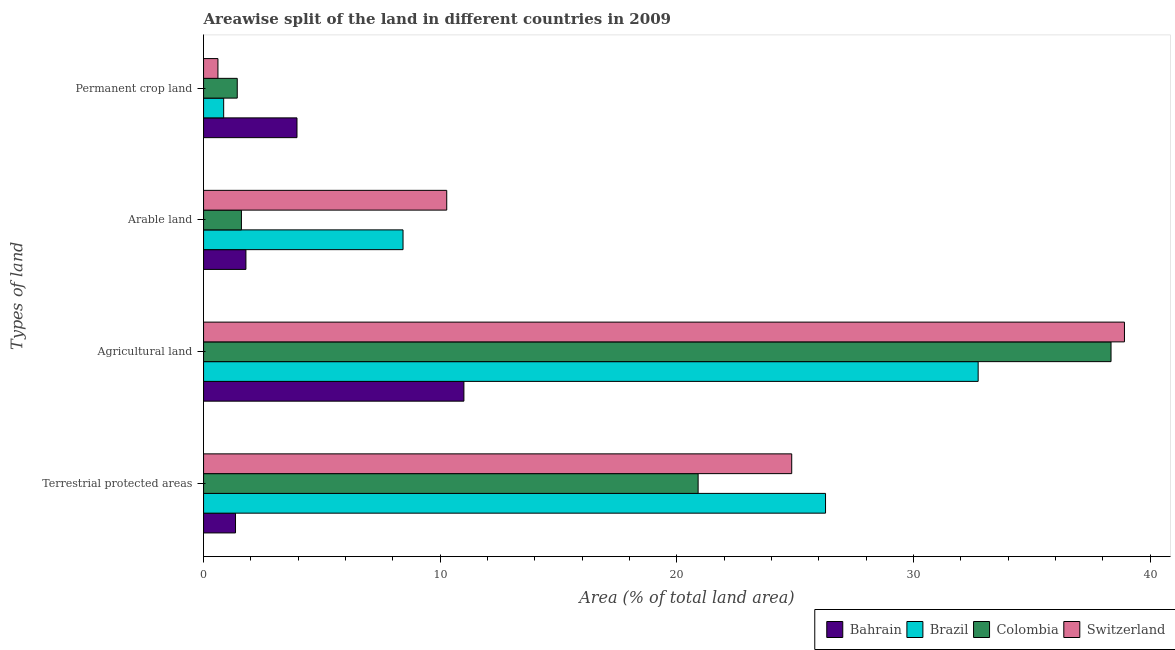How many groups of bars are there?
Provide a succinct answer. 4. How many bars are there on the 3rd tick from the bottom?
Offer a very short reply. 4. What is the label of the 1st group of bars from the top?
Provide a short and direct response. Permanent crop land. What is the percentage of land under terrestrial protection in Colombia?
Offer a very short reply. 20.9. Across all countries, what is the maximum percentage of area under arable land?
Keep it short and to the point. 10.27. Across all countries, what is the minimum percentage of area under permanent crop land?
Give a very brief answer. 0.61. In which country was the percentage of area under agricultural land maximum?
Your answer should be very brief. Switzerland. What is the total percentage of area under arable land in the graph?
Give a very brief answer. 22.09. What is the difference between the percentage of area under arable land in Bahrain and that in Brazil?
Your response must be concise. -6.64. What is the difference between the percentage of area under agricultural land in Switzerland and the percentage of area under arable land in Bahrain?
Your response must be concise. 37.12. What is the average percentage of area under arable land per country?
Keep it short and to the point. 5.52. What is the difference between the percentage of area under arable land and percentage of land under terrestrial protection in Switzerland?
Keep it short and to the point. -14.58. What is the ratio of the percentage of area under agricultural land in Brazil to that in Colombia?
Your answer should be compact. 0.85. What is the difference between the highest and the second highest percentage of area under permanent crop land?
Provide a succinct answer. 2.52. What is the difference between the highest and the lowest percentage of land under terrestrial protection?
Your answer should be compact. 24.93. Is it the case that in every country, the sum of the percentage of area under permanent crop land and percentage of area under agricultural land is greater than the sum of percentage of area under arable land and percentage of land under terrestrial protection?
Make the answer very short. Yes. What does the 3rd bar from the top in Arable land represents?
Offer a very short reply. Brazil. What does the 4th bar from the bottom in Terrestrial protected areas represents?
Your answer should be compact. Switzerland. Is it the case that in every country, the sum of the percentage of land under terrestrial protection and percentage of area under agricultural land is greater than the percentage of area under arable land?
Give a very brief answer. Yes. Are the values on the major ticks of X-axis written in scientific E-notation?
Offer a very short reply. No. Does the graph contain any zero values?
Ensure brevity in your answer.  No. Does the graph contain grids?
Give a very brief answer. No. Where does the legend appear in the graph?
Your answer should be compact. Bottom right. How are the legend labels stacked?
Your answer should be very brief. Horizontal. What is the title of the graph?
Keep it short and to the point. Areawise split of the land in different countries in 2009. Does "Somalia" appear as one of the legend labels in the graph?
Your answer should be compact. No. What is the label or title of the X-axis?
Offer a terse response. Area (% of total land area). What is the label or title of the Y-axis?
Offer a terse response. Types of land. What is the Area (% of total land area) of Bahrain in Terrestrial protected areas?
Your response must be concise. 1.35. What is the Area (% of total land area) of Brazil in Terrestrial protected areas?
Keep it short and to the point. 26.28. What is the Area (% of total land area) of Colombia in Terrestrial protected areas?
Ensure brevity in your answer.  20.9. What is the Area (% of total land area) of Switzerland in Terrestrial protected areas?
Offer a terse response. 24.85. What is the Area (% of total land area) of Bahrain in Agricultural land?
Offer a terse response. 11. What is the Area (% of total land area) of Brazil in Agricultural land?
Your response must be concise. 32.73. What is the Area (% of total land area) in Colombia in Agricultural land?
Keep it short and to the point. 38.34. What is the Area (% of total land area) of Switzerland in Agricultural land?
Keep it short and to the point. 38.91. What is the Area (% of total land area) in Bahrain in Arable land?
Ensure brevity in your answer.  1.79. What is the Area (% of total land area) of Brazil in Arable land?
Provide a succinct answer. 8.43. What is the Area (% of total land area) in Colombia in Arable land?
Ensure brevity in your answer.  1.6. What is the Area (% of total land area) of Switzerland in Arable land?
Offer a terse response. 10.27. What is the Area (% of total land area) of Bahrain in Permanent crop land?
Provide a succinct answer. 3.95. What is the Area (% of total land area) in Brazil in Permanent crop land?
Give a very brief answer. 0.85. What is the Area (% of total land area) of Colombia in Permanent crop land?
Give a very brief answer. 1.42. What is the Area (% of total land area) of Switzerland in Permanent crop land?
Keep it short and to the point. 0.61. Across all Types of land, what is the maximum Area (% of total land area) in Bahrain?
Provide a short and direct response. 11. Across all Types of land, what is the maximum Area (% of total land area) of Brazil?
Your answer should be very brief. 32.73. Across all Types of land, what is the maximum Area (% of total land area) in Colombia?
Provide a short and direct response. 38.34. Across all Types of land, what is the maximum Area (% of total land area) of Switzerland?
Your response must be concise. 38.91. Across all Types of land, what is the minimum Area (% of total land area) of Bahrain?
Your response must be concise. 1.35. Across all Types of land, what is the minimum Area (% of total land area) in Brazil?
Offer a very short reply. 0.85. Across all Types of land, what is the minimum Area (% of total land area) in Colombia?
Offer a terse response. 1.42. Across all Types of land, what is the minimum Area (% of total land area) in Switzerland?
Make the answer very short. 0.61. What is the total Area (% of total land area) of Bahrain in the graph?
Keep it short and to the point. 18.09. What is the total Area (% of total land area) in Brazil in the graph?
Give a very brief answer. 68.28. What is the total Area (% of total land area) of Colombia in the graph?
Keep it short and to the point. 62.26. What is the total Area (% of total land area) in Switzerland in the graph?
Give a very brief answer. 74.64. What is the difference between the Area (% of total land area) in Bahrain in Terrestrial protected areas and that in Agricultural land?
Make the answer very short. -9.65. What is the difference between the Area (% of total land area) in Brazil in Terrestrial protected areas and that in Agricultural land?
Your answer should be very brief. -6.45. What is the difference between the Area (% of total land area) in Colombia in Terrestrial protected areas and that in Agricultural land?
Offer a terse response. -17.45. What is the difference between the Area (% of total land area) in Switzerland in Terrestrial protected areas and that in Agricultural land?
Offer a terse response. -14.06. What is the difference between the Area (% of total land area) in Bahrain in Terrestrial protected areas and that in Arable land?
Ensure brevity in your answer.  -0.44. What is the difference between the Area (% of total land area) in Brazil in Terrestrial protected areas and that in Arable land?
Your answer should be compact. 17.85. What is the difference between the Area (% of total land area) of Colombia in Terrestrial protected areas and that in Arable land?
Your answer should be very brief. 19.3. What is the difference between the Area (% of total land area) in Switzerland in Terrestrial protected areas and that in Arable land?
Keep it short and to the point. 14.58. What is the difference between the Area (% of total land area) in Bahrain in Terrestrial protected areas and that in Permanent crop land?
Provide a short and direct response. -2.6. What is the difference between the Area (% of total land area) of Brazil in Terrestrial protected areas and that in Permanent crop land?
Provide a short and direct response. 25.43. What is the difference between the Area (% of total land area) in Colombia in Terrestrial protected areas and that in Permanent crop land?
Make the answer very short. 19.47. What is the difference between the Area (% of total land area) in Switzerland in Terrestrial protected areas and that in Permanent crop land?
Offer a very short reply. 24.24. What is the difference between the Area (% of total land area) of Bahrain in Agricultural land and that in Arable land?
Offer a terse response. 9.21. What is the difference between the Area (% of total land area) of Brazil in Agricultural land and that in Arable land?
Provide a succinct answer. 24.3. What is the difference between the Area (% of total land area) in Colombia in Agricultural land and that in Arable land?
Your response must be concise. 36.74. What is the difference between the Area (% of total land area) in Switzerland in Agricultural land and that in Arable land?
Ensure brevity in your answer.  28.63. What is the difference between the Area (% of total land area) of Bahrain in Agricultural land and that in Permanent crop land?
Offer a terse response. 7.05. What is the difference between the Area (% of total land area) of Brazil in Agricultural land and that in Permanent crop land?
Provide a succinct answer. 31.88. What is the difference between the Area (% of total land area) in Colombia in Agricultural land and that in Permanent crop land?
Keep it short and to the point. 36.92. What is the difference between the Area (% of total land area) of Switzerland in Agricultural land and that in Permanent crop land?
Provide a succinct answer. 38.3. What is the difference between the Area (% of total land area) in Bahrain in Arable land and that in Permanent crop land?
Ensure brevity in your answer.  -2.16. What is the difference between the Area (% of total land area) of Brazil in Arable land and that in Permanent crop land?
Give a very brief answer. 7.58. What is the difference between the Area (% of total land area) of Colombia in Arable land and that in Permanent crop land?
Provide a short and direct response. 0.18. What is the difference between the Area (% of total land area) of Switzerland in Arable land and that in Permanent crop land?
Your answer should be compact. 9.67. What is the difference between the Area (% of total land area) of Bahrain in Terrestrial protected areas and the Area (% of total land area) of Brazil in Agricultural land?
Provide a succinct answer. -31.38. What is the difference between the Area (% of total land area) of Bahrain in Terrestrial protected areas and the Area (% of total land area) of Colombia in Agricultural land?
Give a very brief answer. -36.99. What is the difference between the Area (% of total land area) in Bahrain in Terrestrial protected areas and the Area (% of total land area) in Switzerland in Agricultural land?
Ensure brevity in your answer.  -37.56. What is the difference between the Area (% of total land area) of Brazil in Terrestrial protected areas and the Area (% of total land area) of Colombia in Agricultural land?
Offer a very short reply. -12.06. What is the difference between the Area (% of total land area) of Brazil in Terrestrial protected areas and the Area (% of total land area) of Switzerland in Agricultural land?
Your answer should be compact. -12.63. What is the difference between the Area (% of total land area) in Colombia in Terrestrial protected areas and the Area (% of total land area) in Switzerland in Agricultural land?
Your answer should be compact. -18.01. What is the difference between the Area (% of total land area) in Bahrain in Terrestrial protected areas and the Area (% of total land area) in Brazil in Arable land?
Offer a very short reply. -7.08. What is the difference between the Area (% of total land area) of Bahrain in Terrestrial protected areas and the Area (% of total land area) of Switzerland in Arable land?
Give a very brief answer. -8.92. What is the difference between the Area (% of total land area) of Brazil in Terrestrial protected areas and the Area (% of total land area) of Colombia in Arable land?
Ensure brevity in your answer.  24.68. What is the difference between the Area (% of total land area) in Brazil in Terrestrial protected areas and the Area (% of total land area) in Switzerland in Arable land?
Provide a succinct answer. 16. What is the difference between the Area (% of total land area) of Colombia in Terrestrial protected areas and the Area (% of total land area) of Switzerland in Arable land?
Offer a terse response. 10.62. What is the difference between the Area (% of total land area) in Bahrain in Terrestrial protected areas and the Area (% of total land area) in Brazil in Permanent crop land?
Give a very brief answer. 0.5. What is the difference between the Area (% of total land area) in Bahrain in Terrestrial protected areas and the Area (% of total land area) in Colombia in Permanent crop land?
Make the answer very short. -0.07. What is the difference between the Area (% of total land area) in Bahrain in Terrestrial protected areas and the Area (% of total land area) in Switzerland in Permanent crop land?
Provide a succinct answer. 0.74. What is the difference between the Area (% of total land area) of Brazil in Terrestrial protected areas and the Area (% of total land area) of Colombia in Permanent crop land?
Your answer should be very brief. 24.86. What is the difference between the Area (% of total land area) of Brazil in Terrestrial protected areas and the Area (% of total land area) of Switzerland in Permanent crop land?
Your answer should be very brief. 25.67. What is the difference between the Area (% of total land area) of Colombia in Terrestrial protected areas and the Area (% of total land area) of Switzerland in Permanent crop land?
Your answer should be compact. 20.29. What is the difference between the Area (% of total land area) in Bahrain in Agricultural land and the Area (% of total land area) in Brazil in Arable land?
Your answer should be very brief. 2.57. What is the difference between the Area (% of total land area) in Bahrain in Agricultural land and the Area (% of total land area) in Colombia in Arable land?
Make the answer very short. 9.4. What is the difference between the Area (% of total land area) of Bahrain in Agricultural land and the Area (% of total land area) of Switzerland in Arable land?
Provide a short and direct response. 0.73. What is the difference between the Area (% of total land area) in Brazil in Agricultural land and the Area (% of total land area) in Colombia in Arable land?
Your answer should be compact. 31.13. What is the difference between the Area (% of total land area) of Brazil in Agricultural land and the Area (% of total land area) of Switzerland in Arable land?
Your answer should be compact. 22.45. What is the difference between the Area (% of total land area) of Colombia in Agricultural land and the Area (% of total land area) of Switzerland in Arable land?
Provide a succinct answer. 28.07. What is the difference between the Area (% of total land area) in Bahrain in Agricultural land and the Area (% of total land area) in Brazil in Permanent crop land?
Make the answer very short. 10.15. What is the difference between the Area (% of total land area) in Bahrain in Agricultural land and the Area (% of total land area) in Colombia in Permanent crop land?
Offer a terse response. 9.58. What is the difference between the Area (% of total land area) of Bahrain in Agricultural land and the Area (% of total land area) of Switzerland in Permanent crop land?
Give a very brief answer. 10.39. What is the difference between the Area (% of total land area) in Brazil in Agricultural land and the Area (% of total land area) in Colombia in Permanent crop land?
Your response must be concise. 31.3. What is the difference between the Area (% of total land area) in Brazil in Agricultural land and the Area (% of total land area) in Switzerland in Permanent crop land?
Offer a terse response. 32.12. What is the difference between the Area (% of total land area) of Colombia in Agricultural land and the Area (% of total land area) of Switzerland in Permanent crop land?
Your answer should be very brief. 37.73. What is the difference between the Area (% of total land area) of Bahrain in Arable land and the Area (% of total land area) of Colombia in Permanent crop land?
Provide a short and direct response. 0.37. What is the difference between the Area (% of total land area) of Bahrain in Arable land and the Area (% of total land area) of Switzerland in Permanent crop land?
Offer a very short reply. 1.18. What is the difference between the Area (% of total land area) of Brazil in Arable land and the Area (% of total land area) of Colombia in Permanent crop land?
Your answer should be compact. 7. What is the difference between the Area (% of total land area) of Brazil in Arable land and the Area (% of total land area) of Switzerland in Permanent crop land?
Provide a succinct answer. 7.82. What is the average Area (% of total land area) in Bahrain per Types of land?
Ensure brevity in your answer.  4.52. What is the average Area (% of total land area) in Brazil per Types of land?
Offer a terse response. 17.07. What is the average Area (% of total land area) in Colombia per Types of land?
Your answer should be very brief. 15.57. What is the average Area (% of total land area) in Switzerland per Types of land?
Make the answer very short. 18.66. What is the difference between the Area (% of total land area) in Bahrain and Area (% of total land area) in Brazil in Terrestrial protected areas?
Provide a succinct answer. -24.93. What is the difference between the Area (% of total land area) of Bahrain and Area (% of total land area) of Colombia in Terrestrial protected areas?
Give a very brief answer. -19.55. What is the difference between the Area (% of total land area) in Bahrain and Area (% of total land area) in Switzerland in Terrestrial protected areas?
Give a very brief answer. -23.5. What is the difference between the Area (% of total land area) in Brazil and Area (% of total land area) in Colombia in Terrestrial protected areas?
Ensure brevity in your answer.  5.38. What is the difference between the Area (% of total land area) of Brazil and Area (% of total land area) of Switzerland in Terrestrial protected areas?
Provide a short and direct response. 1.43. What is the difference between the Area (% of total land area) in Colombia and Area (% of total land area) in Switzerland in Terrestrial protected areas?
Your answer should be compact. -3.95. What is the difference between the Area (% of total land area) of Bahrain and Area (% of total land area) of Brazil in Agricultural land?
Provide a short and direct response. -21.73. What is the difference between the Area (% of total land area) in Bahrain and Area (% of total land area) in Colombia in Agricultural land?
Make the answer very short. -27.34. What is the difference between the Area (% of total land area) in Bahrain and Area (% of total land area) in Switzerland in Agricultural land?
Keep it short and to the point. -27.91. What is the difference between the Area (% of total land area) in Brazil and Area (% of total land area) in Colombia in Agricultural land?
Provide a succinct answer. -5.61. What is the difference between the Area (% of total land area) of Brazil and Area (% of total land area) of Switzerland in Agricultural land?
Make the answer very short. -6.18. What is the difference between the Area (% of total land area) of Colombia and Area (% of total land area) of Switzerland in Agricultural land?
Provide a succinct answer. -0.57. What is the difference between the Area (% of total land area) in Bahrain and Area (% of total land area) in Brazil in Arable land?
Offer a terse response. -6.64. What is the difference between the Area (% of total land area) of Bahrain and Area (% of total land area) of Colombia in Arable land?
Ensure brevity in your answer.  0.19. What is the difference between the Area (% of total land area) of Bahrain and Area (% of total land area) of Switzerland in Arable land?
Offer a terse response. -8.48. What is the difference between the Area (% of total land area) of Brazil and Area (% of total land area) of Colombia in Arable land?
Ensure brevity in your answer.  6.83. What is the difference between the Area (% of total land area) in Brazil and Area (% of total land area) in Switzerland in Arable land?
Your response must be concise. -1.85. What is the difference between the Area (% of total land area) in Colombia and Area (% of total land area) in Switzerland in Arable land?
Ensure brevity in your answer.  -8.67. What is the difference between the Area (% of total land area) in Bahrain and Area (% of total land area) in Brazil in Permanent crop land?
Give a very brief answer. 3.1. What is the difference between the Area (% of total land area) of Bahrain and Area (% of total land area) of Colombia in Permanent crop land?
Keep it short and to the point. 2.52. What is the difference between the Area (% of total land area) of Bahrain and Area (% of total land area) of Switzerland in Permanent crop land?
Provide a succinct answer. 3.34. What is the difference between the Area (% of total land area) in Brazil and Area (% of total land area) in Colombia in Permanent crop land?
Offer a terse response. -0.57. What is the difference between the Area (% of total land area) of Brazil and Area (% of total land area) of Switzerland in Permanent crop land?
Offer a very short reply. 0.24. What is the difference between the Area (% of total land area) in Colombia and Area (% of total land area) in Switzerland in Permanent crop land?
Offer a terse response. 0.82. What is the ratio of the Area (% of total land area) in Bahrain in Terrestrial protected areas to that in Agricultural land?
Ensure brevity in your answer.  0.12. What is the ratio of the Area (% of total land area) of Brazil in Terrestrial protected areas to that in Agricultural land?
Offer a terse response. 0.8. What is the ratio of the Area (% of total land area) in Colombia in Terrestrial protected areas to that in Agricultural land?
Offer a very short reply. 0.55. What is the ratio of the Area (% of total land area) of Switzerland in Terrestrial protected areas to that in Agricultural land?
Offer a terse response. 0.64. What is the ratio of the Area (% of total land area) in Bahrain in Terrestrial protected areas to that in Arable land?
Your answer should be very brief. 0.75. What is the ratio of the Area (% of total land area) of Brazil in Terrestrial protected areas to that in Arable land?
Your answer should be compact. 3.12. What is the ratio of the Area (% of total land area) of Colombia in Terrestrial protected areas to that in Arable land?
Provide a short and direct response. 13.06. What is the ratio of the Area (% of total land area) in Switzerland in Terrestrial protected areas to that in Arable land?
Your answer should be compact. 2.42. What is the ratio of the Area (% of total land area) of Bahrain in Terrestrial protected areas to that in Permanent crop land?
Offer a terse response. 0.34. What is the ratio of the Area (% of total land area) of Brazil in Terrestrial protected areas to that in Permanent crop land?
Your answer should be very brief. 30.94. What is the ratio of the Area (% of total land area) of Colombia in Terrestrial protected areas to that in Permanent crop land?
Provide a succinct answer. 14.68. What is the ratio of the Area (% of total land area) of Switzerland in Terrestrial protected areas to that in Permanent crop land?
Provide a short and direct response. 40.92. What is the ratio of the Area (% of total land area) in Bahrain in Agricultural land to that in Arable land?
Give a very brief answer. 6.15. What is the ratio of the Area (% of total land area) in Brazil in Agricultural land to that in Arable land?
Offer a terse response. 3.88. What is the ratio of the Area (% of total land area) of Colombia in Agricultural land to that in Arable land?
Offer a very short reply. 23.97. What is the ratio of the Area (% of total land area) of Switzerland in Agricultural land to that in Arable land?
Your response must be concise. 3.79. What is the ratio of the Area (% of total land area) of Bahrain in Agricultural land to that in Permanent crop land?
Your answer should be compact. 2.79. What is the ratio of the Area (% of total land area) of Brazil in Agricultural land to that in Permanent crop land?
Offer a terse response. 38.53. What is the ratio of the Area (% of total land area) in Colombia in Agricultural land to that in Permanent crop land?
Offer a terse response. 26.94. What is the ratio of the Area (% of total land area) in Switzerland in Agricultural land to that in Permanent crop land?
Ensure brevity in your answer.  64.06. What is the ratio of the Area (% of total land area) of Bahrain in Arable land to that in Permanent crop land?
Offer a very short reply. 0.45. What is the ratio of the Area (% of total land area) in Brazil in Arable land to that in Permanent crop land?
Your response must be concise. 9.92. What is the ratio of the Area (% of total land area) in Colombia in Arable land to that in Permanent crop land?
Offer a terse response. 1.12. What is the ratio of the Area (% of total land area) in Switzerland in Arable land to that in Permanent crop land?
Keep it short and to the point. 16.92. What is the difference between the highest and the second highest Area (% of total land area) in Bahrain?
Ensure brevity in your answer.  7.05. What is the difference between the highest and the second highest Area (% of total land area) in Brazil?
Keep it short and to the point. 6.45. What is the difference between the highest and the second highest Area (% of total land area) of Colombia?
Offer a terse response. 17.45. What is the difference between the highest and the second highest Area (% of total land area) of Switzerland?
Ensure brevity in your answer.  14.06. What is the difference between the highest and the lowest Area (% of total land area) of Bahrain?
Provide a succinct answer. 9.65. What is the difference between the highest and the lowest Area (% of total land area) in Brazil?
Offer a very short reply. 31.88. What is the difference between the highest and the lowest Area (% of total land area) in Colombia?
Give a very brief answer. 36.92. What is the difference between the highest and the lowest Area (% of total land area) in Switzerland?
Keep it short and to the point. 38.3. 